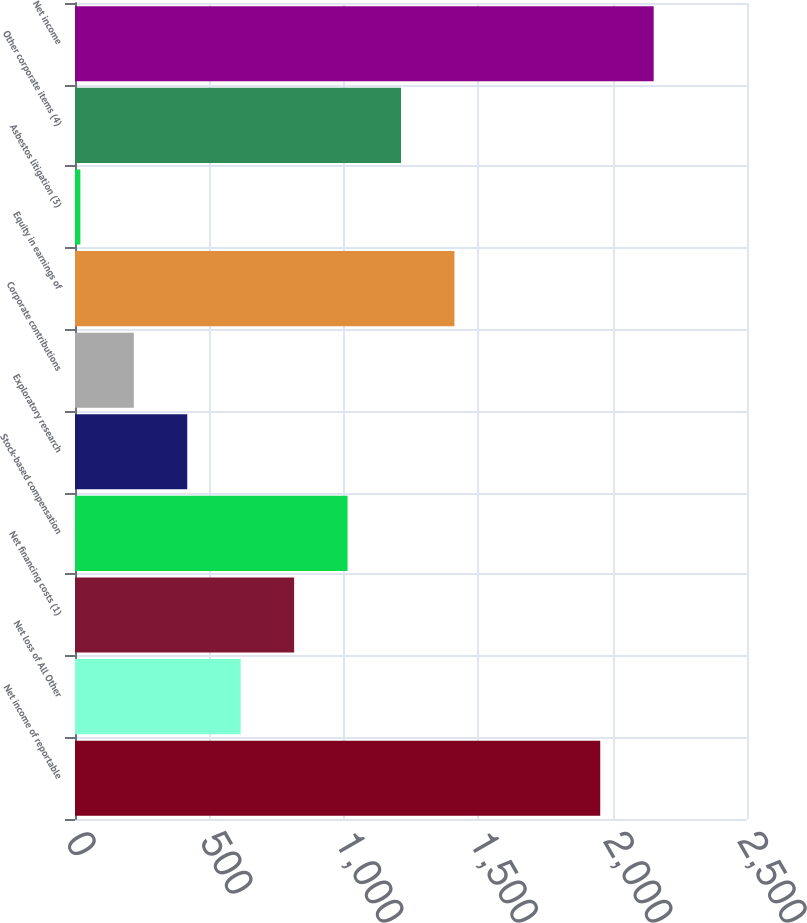<chart> <loc_0><loc_0><loc_500><loc_500><bar_chart><fcel>Net income of reportable<fcel>Net loss of All Other<fcel>Net financing costs (1)<fcel>Stock-based compensation<fcel>Exploratory research<fcel>Corporate contributions<fcel>Equity in earnings of<fcel>Asbestos litigation (3)<fcel>Other corporate items (4)<fcel>Net income<nl><fcel>1954<fcel>616.4<fcel>815.2<fcel>1014<fcel>417.6<fcel>218.8<fcel>1411.6<fcel>20<fcel>1212.8<fcel>2152.8<nl></chart> 